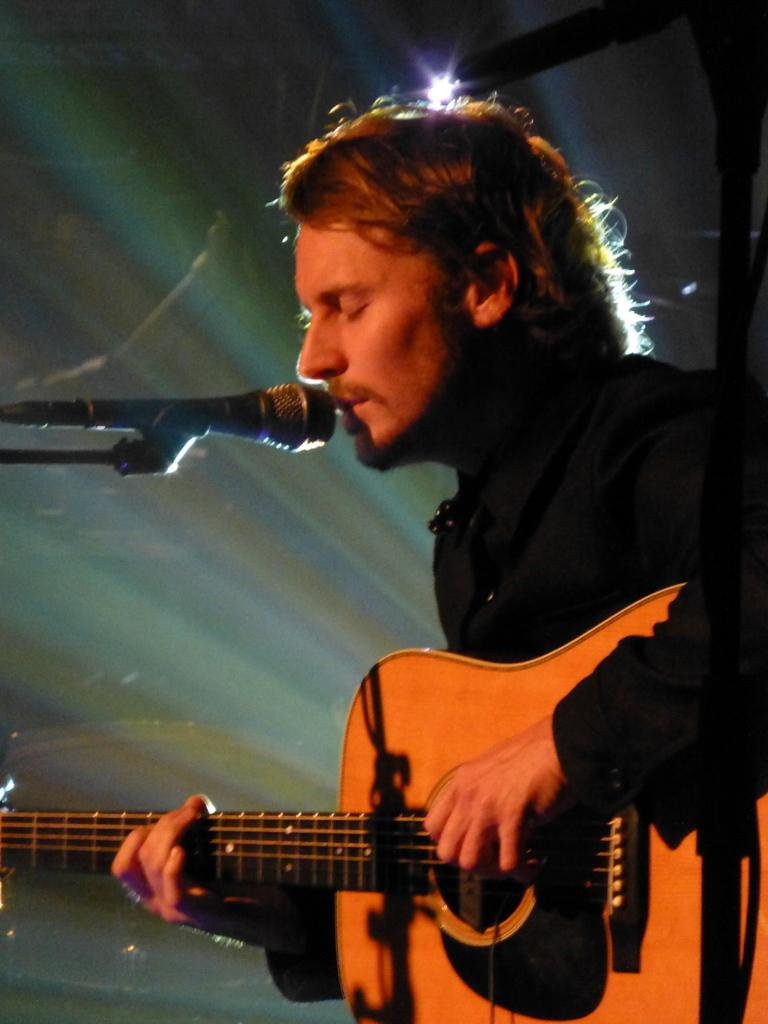What is the man in the image doing? The man is singing in the image. What object is the man holding in the image? The man is holding a guitar in the image. How is the man's voice being amplified in the image? The man is using a microphone in the image. What part of the man's body is being treated in the image? There is no indication in the image that the man is receiving any treatment; he is singing and holding a guitar. 